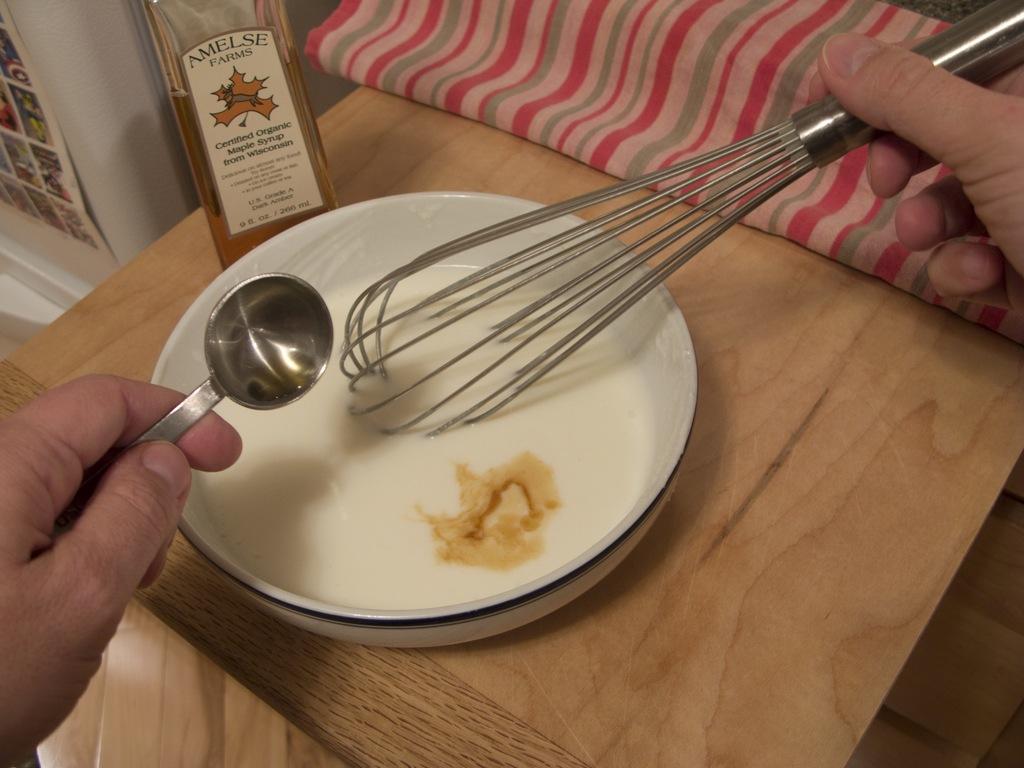Please provide a concise description of this image. In this picture we can see a person's hand holding a spoon, whisk and on the table we can see a cloth, bottle, bowl with food in it and in the background we can see a poster. 